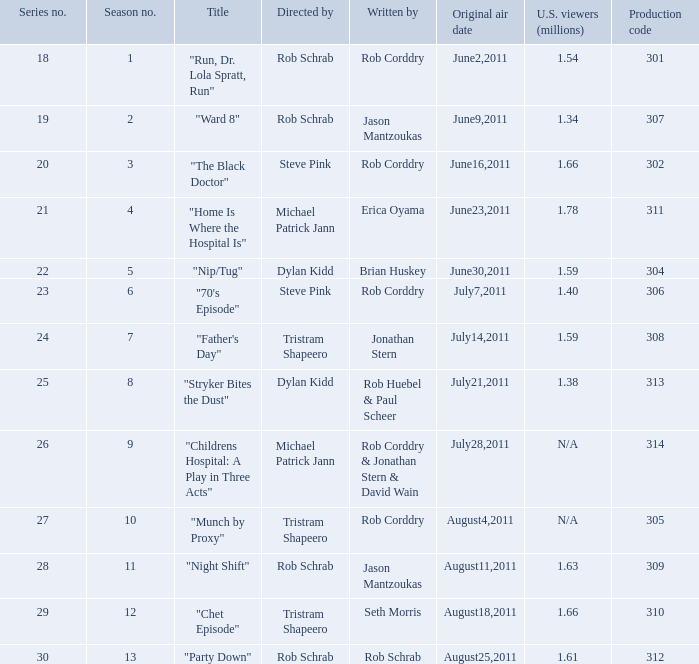The episode entitled "ward 8" was what number in the series? 19.0. 